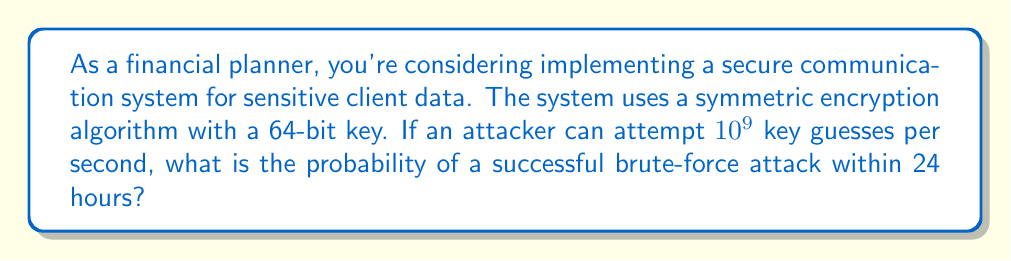Teach me how to tackle this problem. Let's approach this step-by-step:

1) First, we need to calculate the total number of possible keys:
   $$\text{Total keys} = 2^{64}$$

2) Next, let's calculate how many key attempts can be made in 24 hours:
   $$\text{Attempts per day} = 10^9 \times 60 \times 60 \times 24 = 8.64 \times 10^{13}$$

3) The probability of success is the number of attempts divided by the total number of possible keys:
   $$P(\text{success}) = \frac{\text{Attempts per day}}{\text{Total keys}}$$

4) Let's substitute the values:
   $$P(\text{success}) = \frac{8.64 \times 10^{13}}{2^{64}}$$

5) To calculate this, let's convert $2^{64}$ to base 10:
   $$2^{64} \approx 1.8447 \times 10^{19}$$

6) Now we can divide:
   $$P(\text{success}) = \frac{8.64 \times 10^{13}}{1.8447 \times 10^{19}} \approx 4.684 \times 10^{-6}$$

7) This can be expressed as a percentage:
   $$P(\text{success}) \approx 0.0004684\%$$
Answer: $4.684 \times 10^{-6}$ or approximately $0.0004684\%$ 